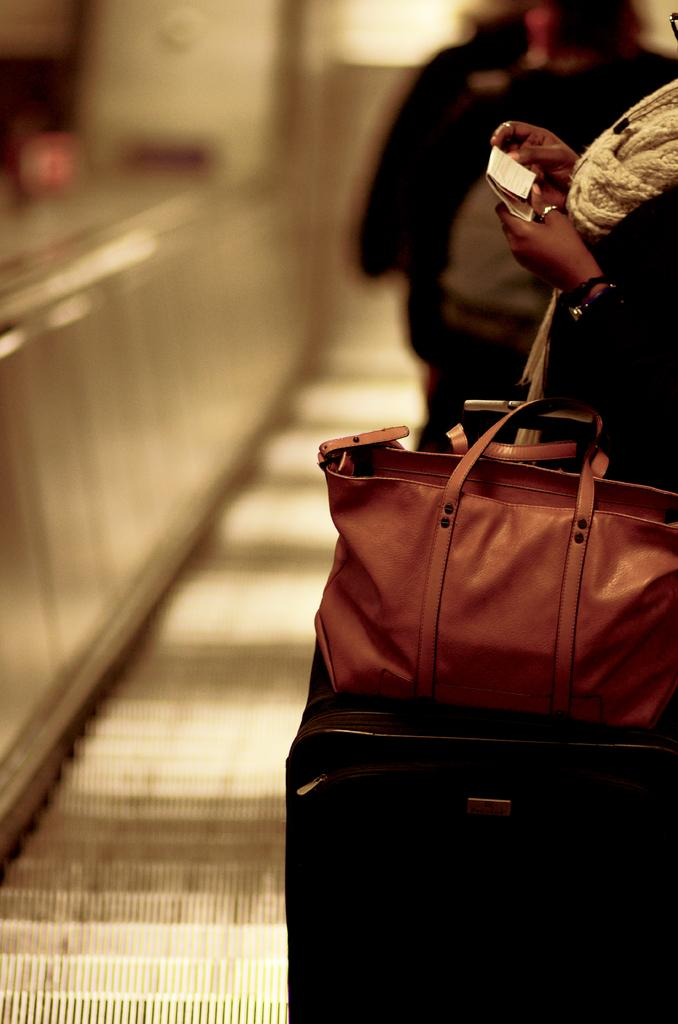Who is present in the image? There is a woman in the image. What is the woman holding? The woman is holding a paper. What type of bags can be seen in the image? There is a handbag and a trolley bag in the image. Can you describe the background of the image? There is a person in the background of the image. What type of thunder can be heard in the image? There is no thunder present in the image, as it is a still photograph. 